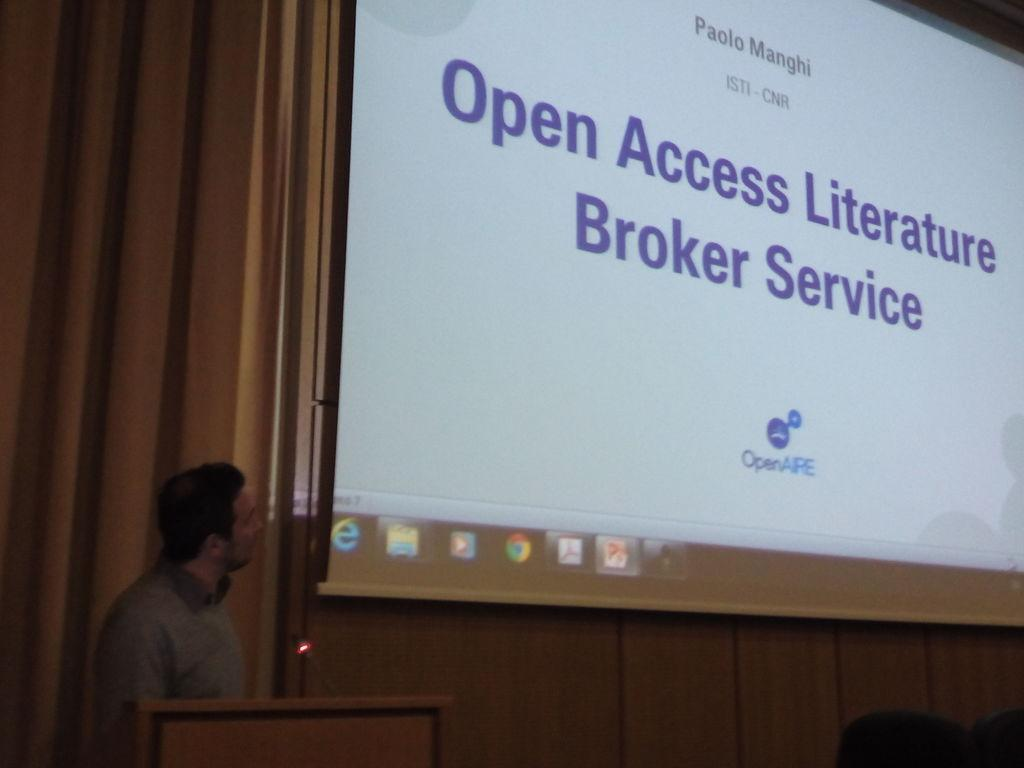Who is present in the image? There is a man in the image. What is the man doing in the image? The man is standing in the image. What object can be seen in the image that is typically used for speeches or presentations? There is a speech desk in the image. What is on the right side of the image? There is a projector screen on the right side of the image. What is being displayed on the projector screen? There is a presentation visible in the image. What type of ornament is hanging from the ceiling in the image? There is no ornament hanging from the ceiling in the image; the image features a man standing near a speech desk with a projector screen displaying a presentation. 